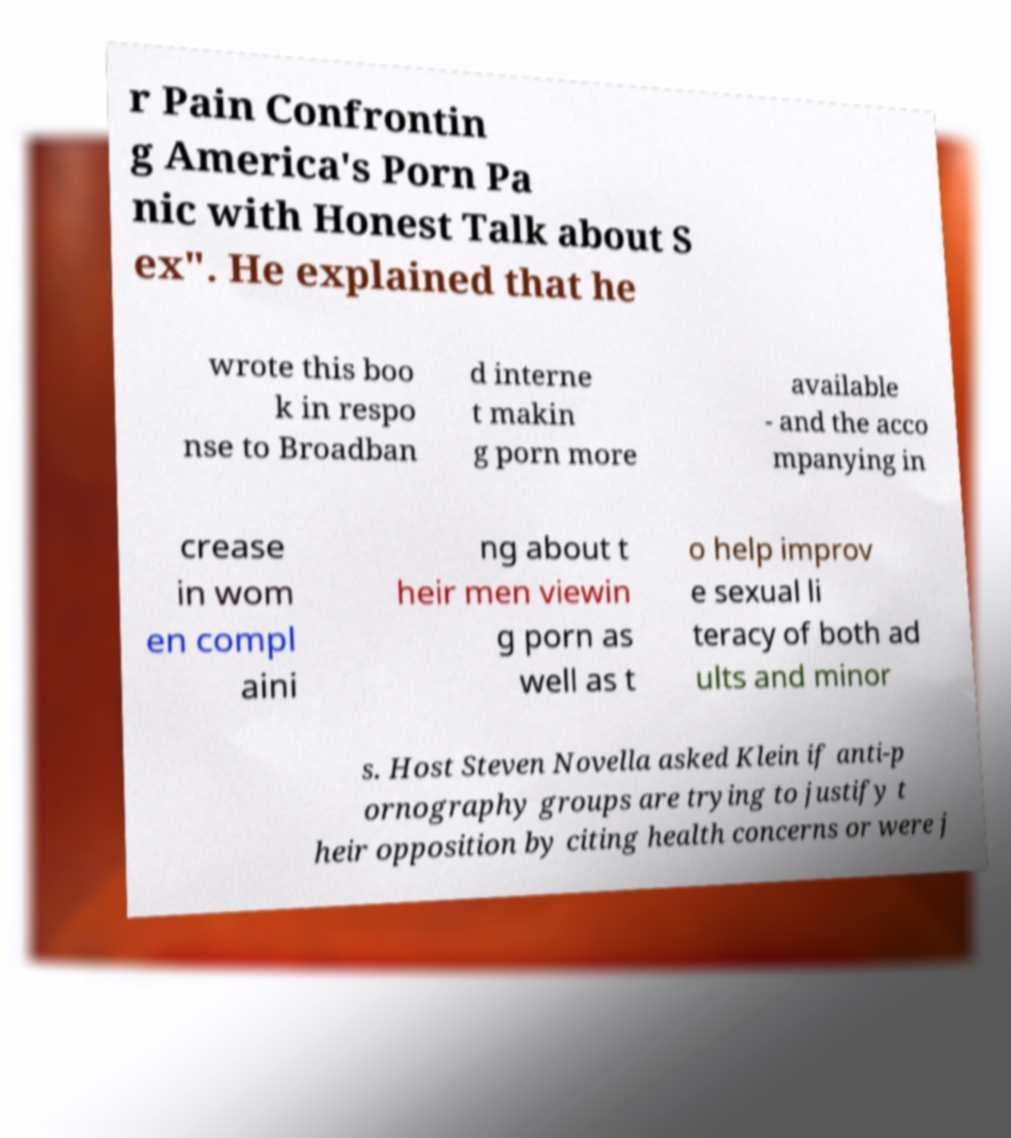Can you accurately transcribe the text from the provided image for me? r Pain Confrontin g America's Porn Pa nic with Honest Talk about S ex". He explained that he wrote this boo k in respo nse to Broadban d interne t makin g porn more available - and the acco mpanying in crease in wom en compl aini ng about t heir men viewin g porn as well as t o help improv e sexual li teracy of both ad ults and minor s. Host Steven Novella asked Klein if anti-p ornography groups are trying to justify t heir opposition by citing health concerns or were j 